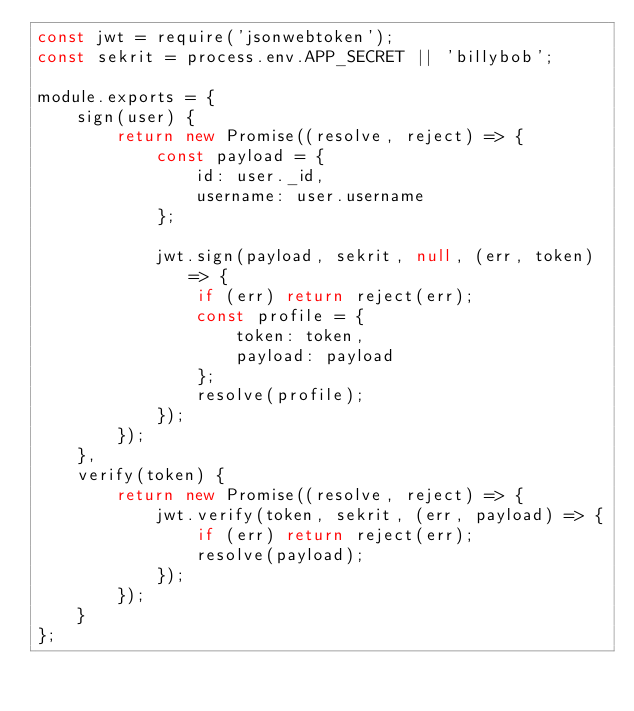Convert code to text. <code><loc_0><loc_0><loc_500><loc_500><_JavaScript_>const jwt = require('jsonwebtoken');
const sekrit = process.env.APP_SECRET || 'billybob';

module.exports = {
    sign(user) {
        return new Promise((resolve, reject) => {
            const payload = {
                id: user._id,
                username: user.username
            };

            jwt.sign(payload, sekrit, null, (err, token) => {
                if (err) return reject(err);
                const profile = {
                    token: token,
                    payload: payload
                };
                resolve(profile);
            });
        });
    },
    verify(token) {
        return new Promise((resolve, reject) => {
            jwt.verify(token, sekrit, (err, payload) => {
                if (err) return reject(err);
                resolve(payload);
            });
        });
    }
};</code> 